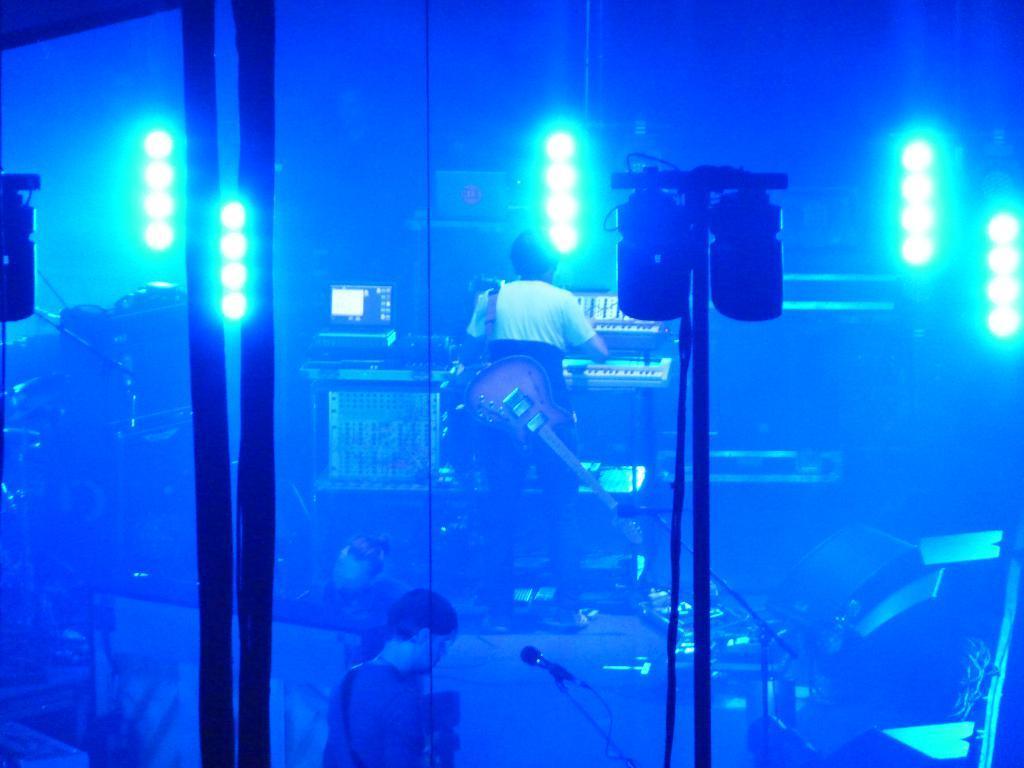Can you describe this image briefly? This image is taken indoors. At the bottom of the image there is a floor and there is a man. There are two mics. In the middle of the image a man is standing on the floor and there are a few musical instruments and he is holding a guitar. There are a few lights. There are many things on the floor. 